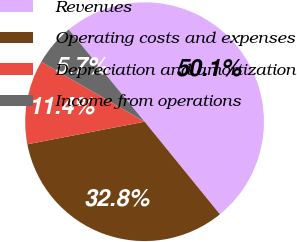Convert chart to OTSL. <chart><loc_0><loc_0><loc_500><loc_500><pie_chart><fcel>Revenues<fcel>Operating costs and expenses<fcel>Depreciation and amortization<fcel>Income from operations<nl><fcel>50.1%<fcel>32.83%<fcel>11.39%<fcel>5.68%<nl></chart> 